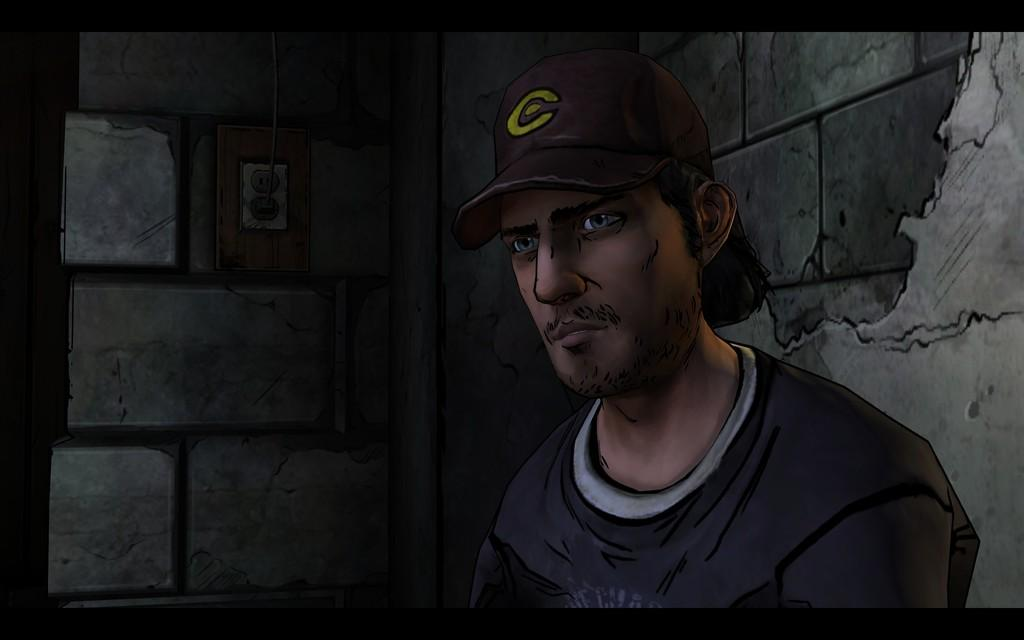What type of image is depicted in the picture? There is a cartoon of a person in the image. What is the person in the cartoon wearing on their head? The person is wearing a cap. What can be seen in the background of the image? There is a wall and other objects visible in the background of the image. How does the person in the cartoon feel about their upcoming vacation? There is no indication of a vacation or any feelings in the image, as it only features a cartoon person wearing a cap. 